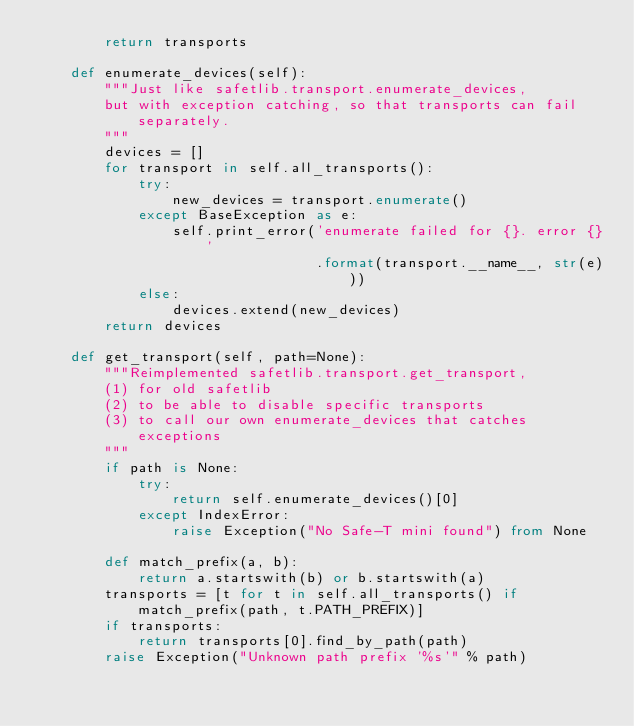<code> <loc_0><loc_0><loc_500><loc_500><_Python_>        return transports

    def enumerate_devices(self):
        """Just like safetlib.transport.enumerate_devices,
        but with exception catching, so that transports can fail separately.
        """
        devices = []
        for transport in self.all_transports():
            try:
                new_devices = transport.enumerate()
            except BaseException as e:
                self.print_error('enumerate failed for {}. error {}'
                                 .format(transport.__name__, str(e)))
            else:
                devices.extend(new_devices)
        return devices

    def get_transport(self, path=None):
        """Reimplemented safetlib.transport.get_transport,
        (1) for old safetlib
        (2) to be able to disable specific transports
        (3) to call our own enumerate_devices that catches exceptions
        """
        if path is None:
            try:
                return self.enumerate_devices()[0]
            except IndexError:
                raise Exception("No Safe-T mini found") from None

        def match_prefix(a, b):
            return a.startswith(b) or b.startswith(a)
        transports = [t for t in self.all_transports() if match_prefix(path, t.PATH_PREFIX)]
        if transports:
            return transports[0].find_by_path(path)
        raise Exception("Unknown path prefix '%s'" % path)
</code> 